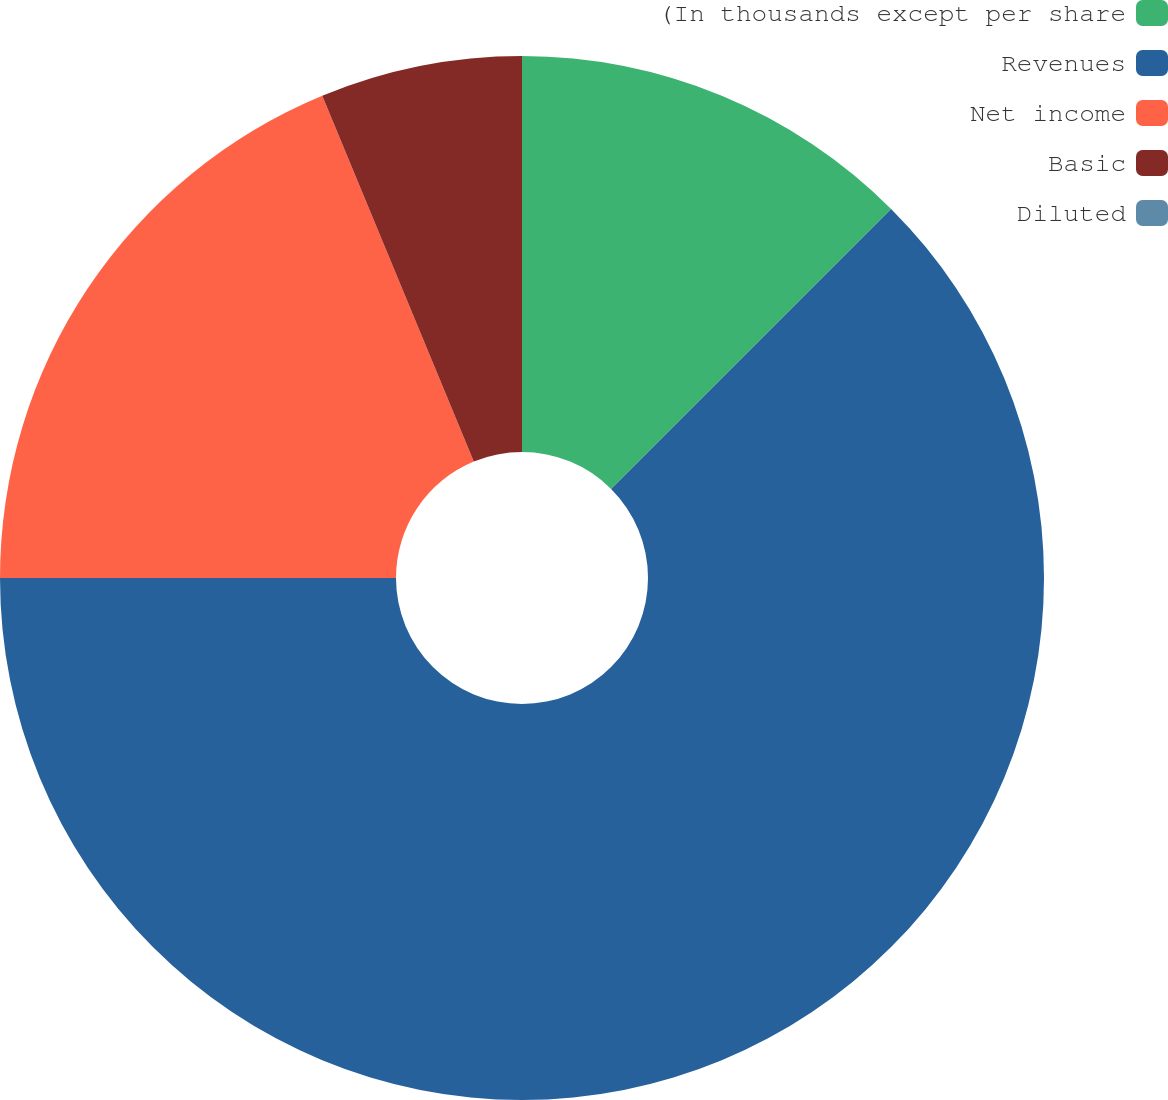Convert chart. <chart><loc_0><loc_0><loc_500><loc_500><pie_chart><fcel>(In thousands except per share<fcel>Revenues<fcel>Net income<fcel>Basic<fcel>Diluted<nl><fcel>12.5%<fcel>62.5%<fcel>18.75%<fcel>6.25%<fcel>0.0%<nl></chart> 